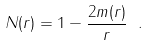<formula> <loc_0><loc_0><loc_500><loc_500>N ( r ) = 1 - \frac { 2 m ( r ) } { r } \ .</formula> 